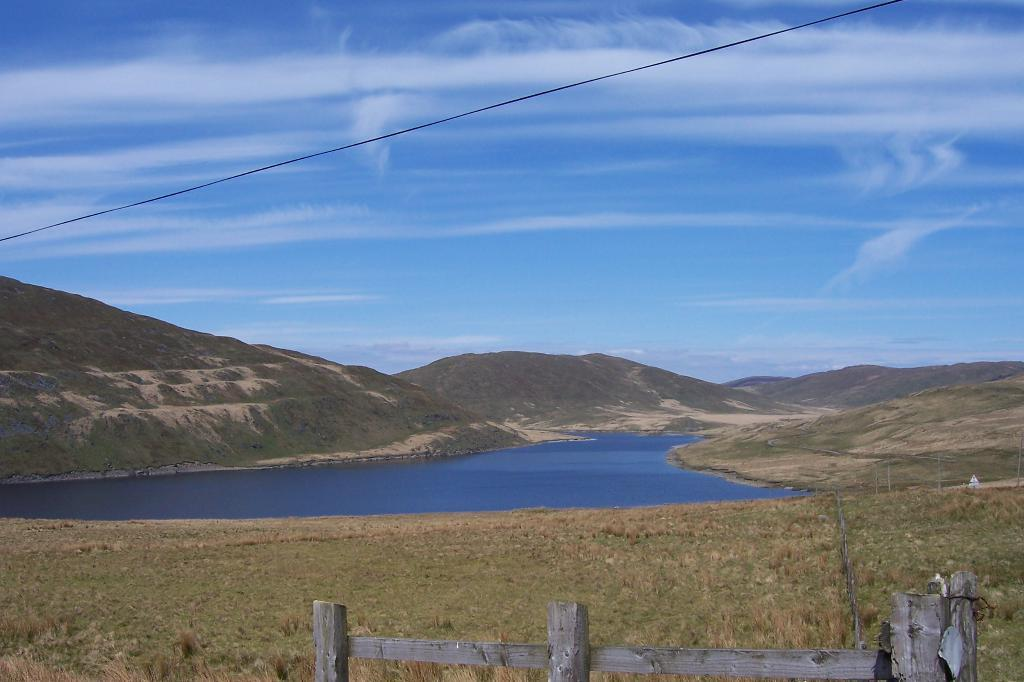What type of terrain is visible in the image? There is grassy land in the image. What body of water can be seen in the image? There is a pond in the image. What type of geological feature is present in the image? There are mountains in the image. How would you describe the sky in the image? The sky is blue with little clouds. What kind of wooden object is at the bottom of the image? A wooden object is present at the bottom of the image. How many chickens are standing near the wooden object in the image? There are no chickens present in the image. What type of stem can be seen growing from the pond in the image? There is no stem growing from the pond in the image. 